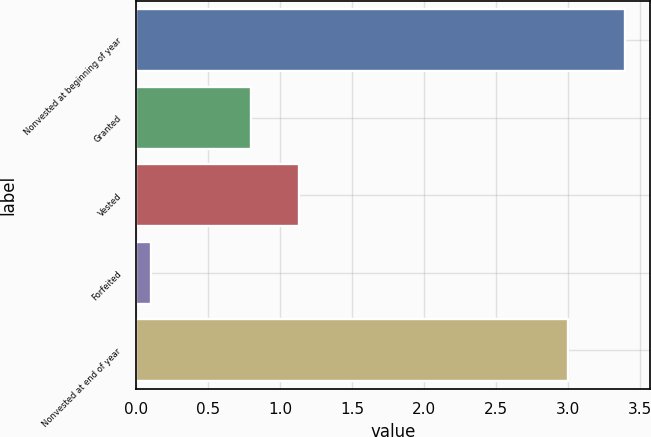Convert chart. <chart><loc_0><loc_0><loc_500><loc_500><bar_chart><fcel>Nonvested at beginning of year<fcel>Granted<fcel>Vested<fcel>Forfeited<fcel>Nonvested at end of year<nl><fcel>3.4<fcel>0.8<fcel>1.13<fcel>0.1<fcel>3<nl></chart> 